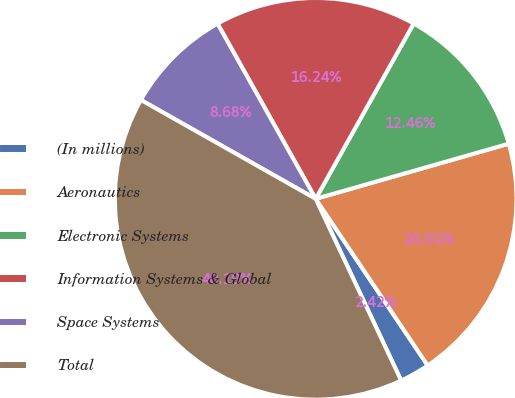<chart> <loc_0><loc_0><loc_500><loc_500><pie_chart><fcel>(In millions)<fcel>Aeronautics<fcel>Electronic Systems<fcel>Information Systems & Global<fcel>Space Systems<fcel>Total<nl><fcel>2.42%<fcel>20.01%<fcel>12.46%<fcel>16.24%<fcel>8.68%<fcel>40.19%<nl></chart> 